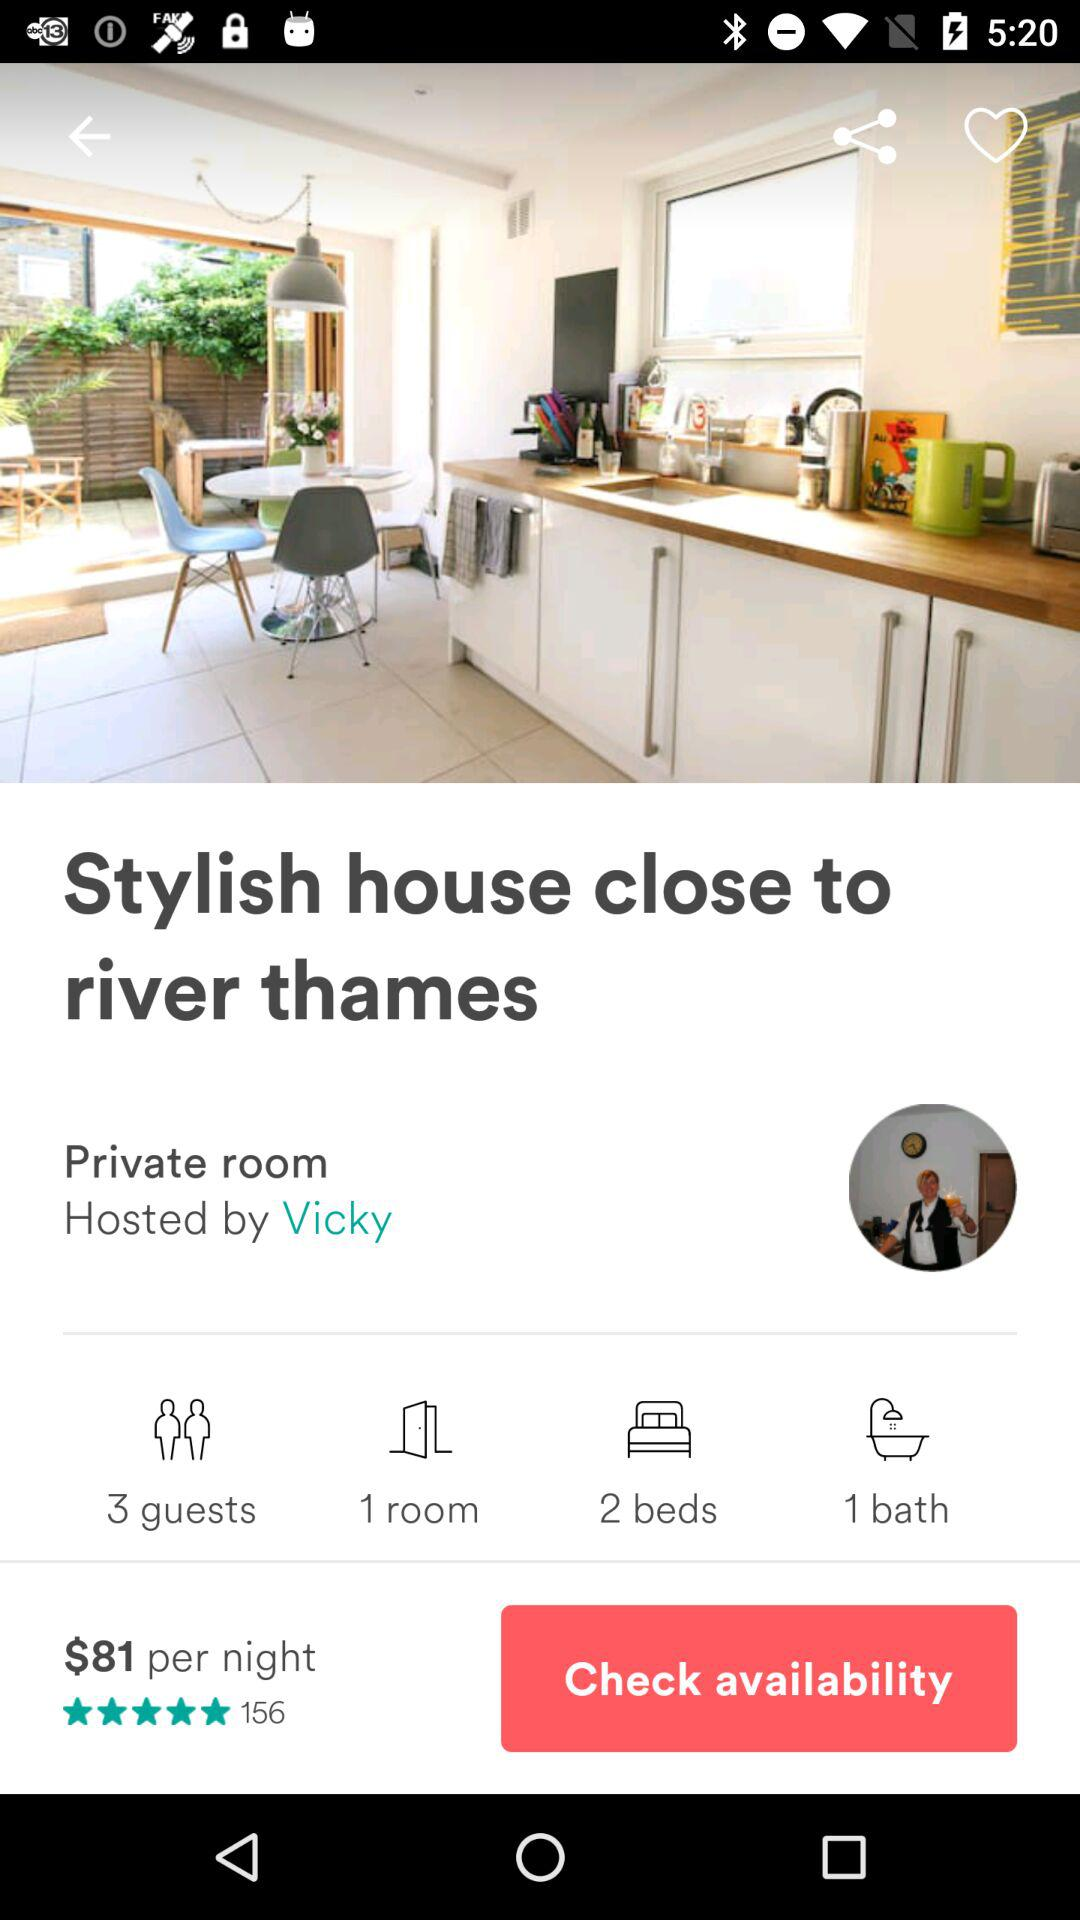What is the number of bathrooms? The number of bathrooms is 1. 